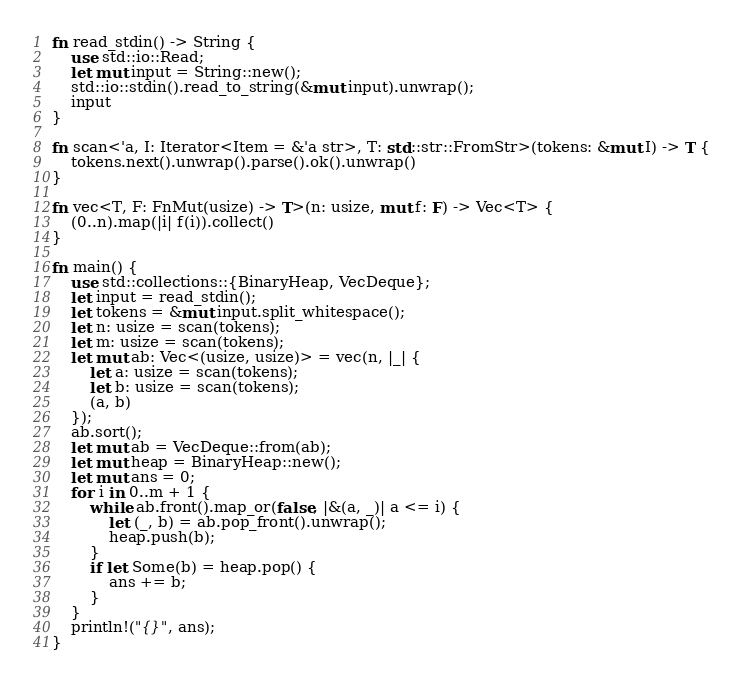<code> <loc_0><loc_0><loc_500><loc_500><_Rust_>fn read_stdin() -> String {
    use std::io::Read;
    let mut input = String::new();
    std::io::stdin().read_to_string(&mut input).unwrap();
    input
}

fn scan<'a, I: Iterator<Item = &'a str>, T: std::str::FromStr>(tokens: &mut I) -> T {
    tokens.next().unwrap().parse().ok().unwrap()
}

fn vec<T, F: FnMut(usize) -> T>(n: usize, mut f: F) -> Vec<T> {
    (0..n).map(|i| f(i)).collect()
}

fn main() {
    use std::collections::{BinaryHeap, VecDeque};
    let input = read_stdin();
    let tokens = &mut input.split_whitespace();
    let n: usize = scan(tokens);
    let m: usize = scan(tokens);
    let mut ab: Vec<(usize, usize)> = vec(n, |_| {
        let a: usize = scan(tokens);
        let b: usize = scan(tokens);
        (a, b)
    });
    ab.sort();
    let mut ab = VecDeque::from(ab);
    let mut heap = BinaryHeap::new();
    let mut ans = 0;
    for i in 0..m + 1 {
        while ab.front().map_or(false, |&(a, _)| a <= i) {
            let (_, b) = ab.pop_front().unwrap();
            heap.push(b);
        }
        if let Some(b) = heap.pop() {
            ans += b;
        }
    }
    println!("{}", ans);
}
</code> 